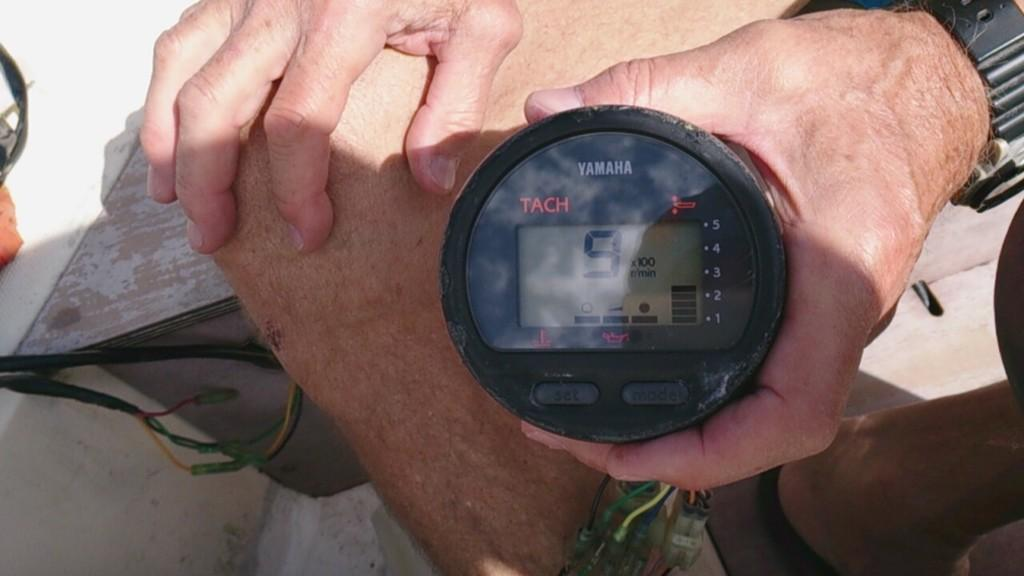<image>
Describe the image concisely. A man is holding a Yamaha meter that reads the number 9 